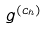<formula> <loc_0><loc_0><loc_500><loc_500>g ^ { ( c _ { h } ) }</formula> 